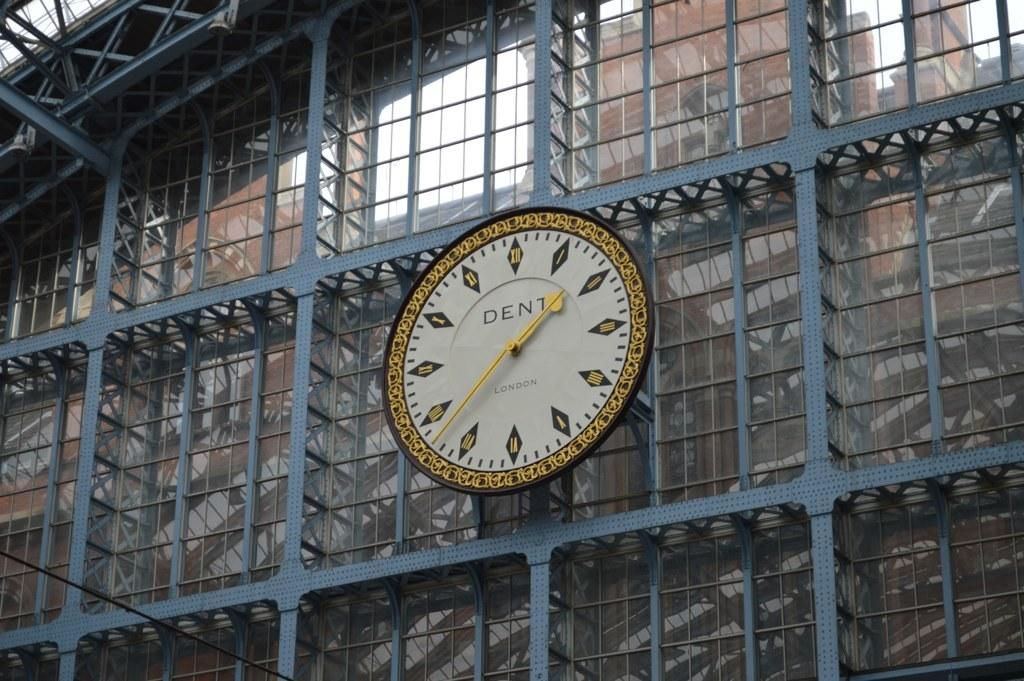What object is attached to the iron grilles in the image? There is a clock on the iron grilles in the image. What can be seen behind the iron grilles? There are transparent glasses behind the iron grilles. What is visible in the background of the image? There is a building and the sky visible in the background. How many family members can be seen in the image? There are no family members present in the image. What type of range is visible in the image? There is no range present in the image. 